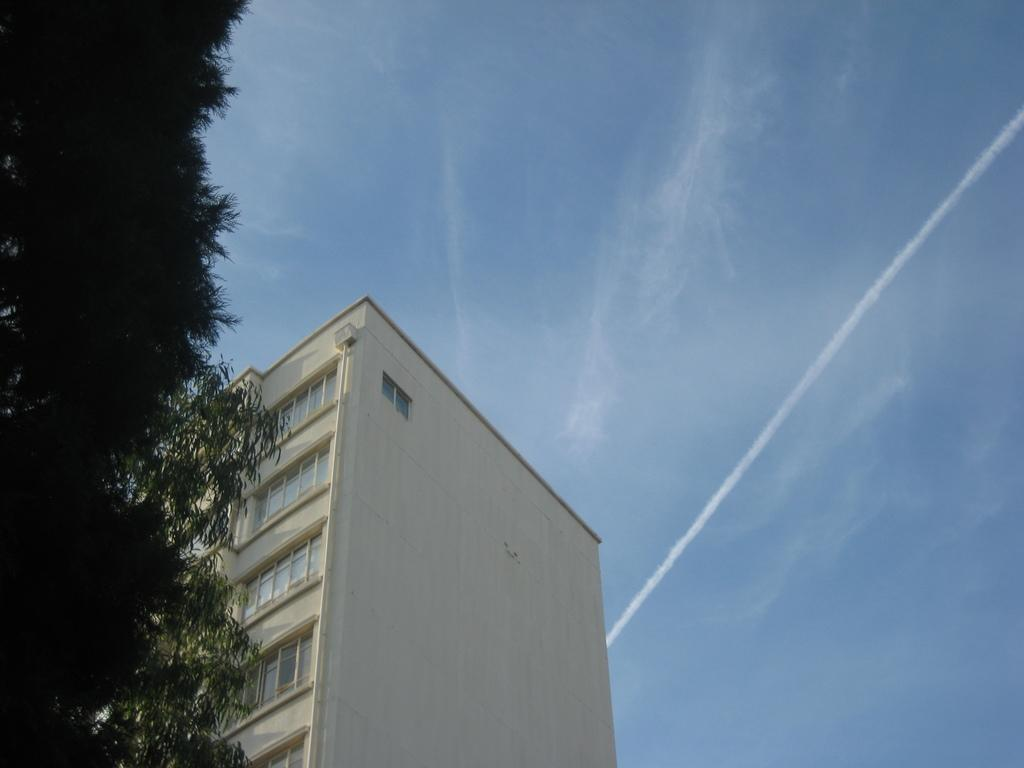What type of structure is present in the image? There is a building in the image. What are the main features of the building's exterior? The building has walls, windows, and a pipe visible in the image. Where is the tree located in relation to the building? The tree is on the left side of the image. What can be seen in the background of the image? The sky is visible in the background of the image. What type of copper tail can be seen on the building in the image? There is no copper tail present on the building in the image. What type of stone is the tree made of in the image? The tree is not made of stone; it is a living plant. 